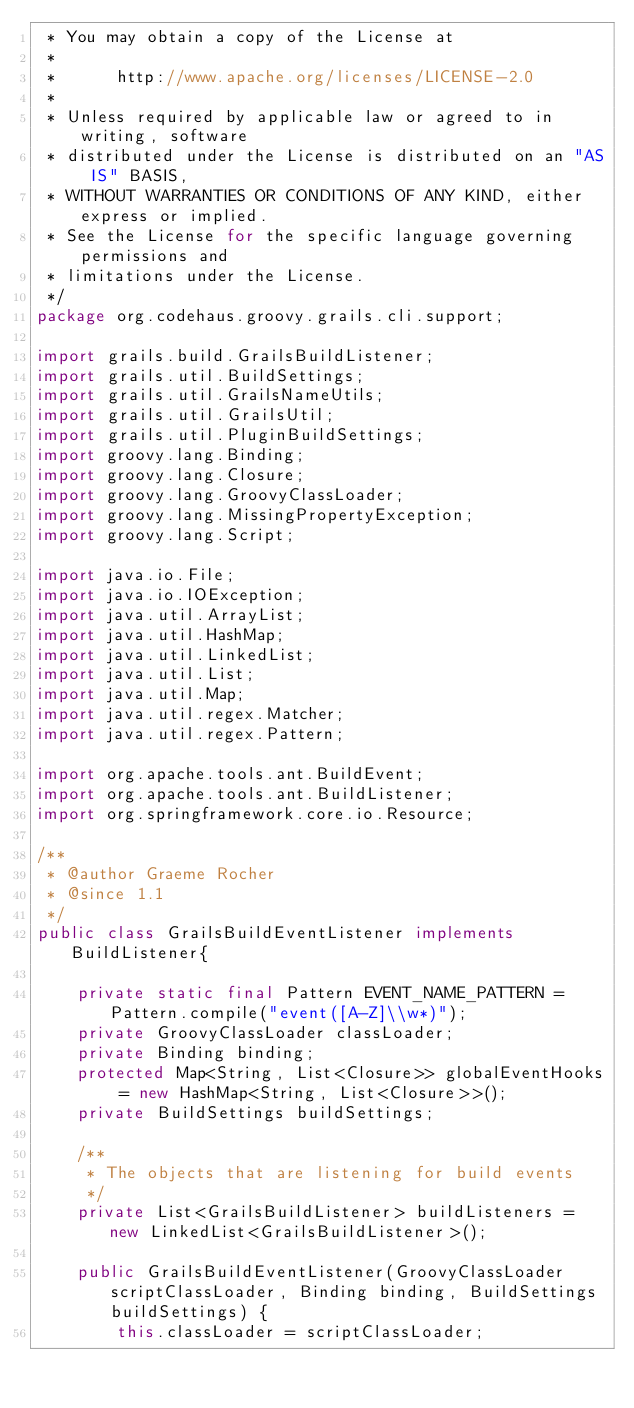<code> <loc_0><loc_0><loc_500><loc_500><_Java_> * You may obtain a copy of the License at
 *
 *      http://www.apache.org/licenses/LICENSE-2.0
 *
 * Unless required by applicable law or agreed to in writing, software
 * distributed under the License is distributed on an "AS IS" BASIS,
 * WITHOUT WARRANTIES OR CONDITIONS OF ANY KIND, either express or implied.
 * See the License for the specific language governing permissions and
 * limitations under the License.
 */
package org.codehaus.groovy.grails.cli.support;

import grails.build.GrailsBuildListener;
import grails.util.BuildSettings;
import grails.util.GrailsNameUtils;
import grails.util.GrailsUtil;
import grails.util.PluginBuildSettings;
import groovy.lang.Binding;
import groovy.lang.Closure;
import groovy.lang.GroovyClassLoader;
import groovy.lang.MissingPropertyException;
import groovy.lang.Script;

import java.io.File;
import java.io.IOException;
import java.util.ArrayList;
import java.util.HashMap;
import java.util.LinkedList;
import java.util.List;
import java.util.Map;
import java.util.regex.Matcher;
import java.util.regex.Pattern;

import org.apache.tools.ant.BuildEvent;
import org.apache.tools.ant.BuildListener;
import org.springframework.core.io.Resource;

/**
 * @author Graeme Rocher
 * @since 1.1
 */
public class GrailsBuildEventListener implements BuildListener{

    private static final Pattern EVENT_NAME_PATTERN = Pattern.compile("event([A-Z]\\w*)");
    private GroovyClassLoader classLoader;
    private Binding binding;
    protected Map<String, List<Closure>> globalEventHooks = new HashMap<String, List<Closure>>();
    private BuildSettings buildSettings;

    /**
     * The objects that are listening for build events
     */
    private List<GrailsBuildListener> buildListeners = new LinkedList<GrailsBuildListener>();

    public GrailsBuildEventListener(GroovyClassLoader scriptClassLoader, Binding binding, BuildSettings buildSettings) {
        this.classLoader = scriptClassLoader;</code> 